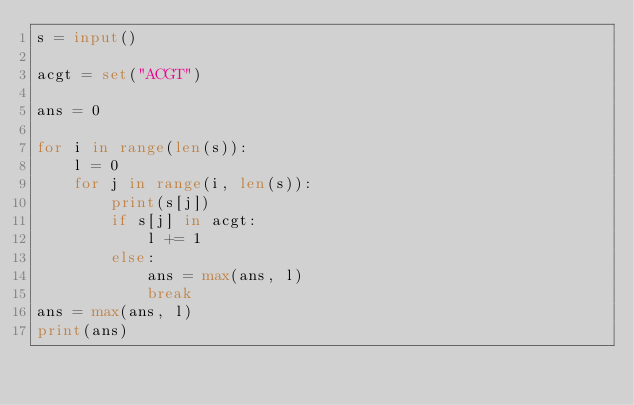<code> <loc_0><loc_0><loc_500><loc_500><_Python_>s = input()

acgt = set("ACGT")

ans = 0

for i in range(len(s)):
    l = 0
    for j in range(i, len(s)):
        print(s[j])
        if s[j] in acgt:
            l += 1
        else:
            ans = max(ans, l)
            break
ans = max(ans, l)
print(ans)
</code> 